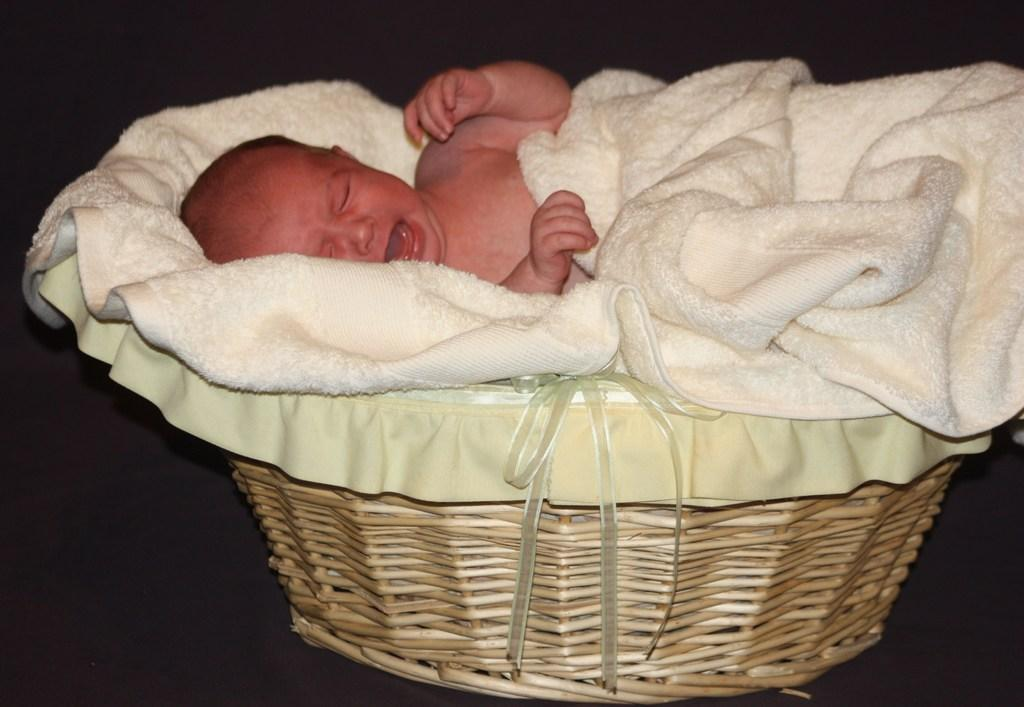What object is present in the image that can hold items? There is a basket in the image. How is the basket being used in the image? The basket is being used to hold a baby, who is lying on it. Is the basket covered in the image? Yes, the basket is covered with a cloth. Can you see a river flowing near the basket in the image? No, there is no river visible in the image. 